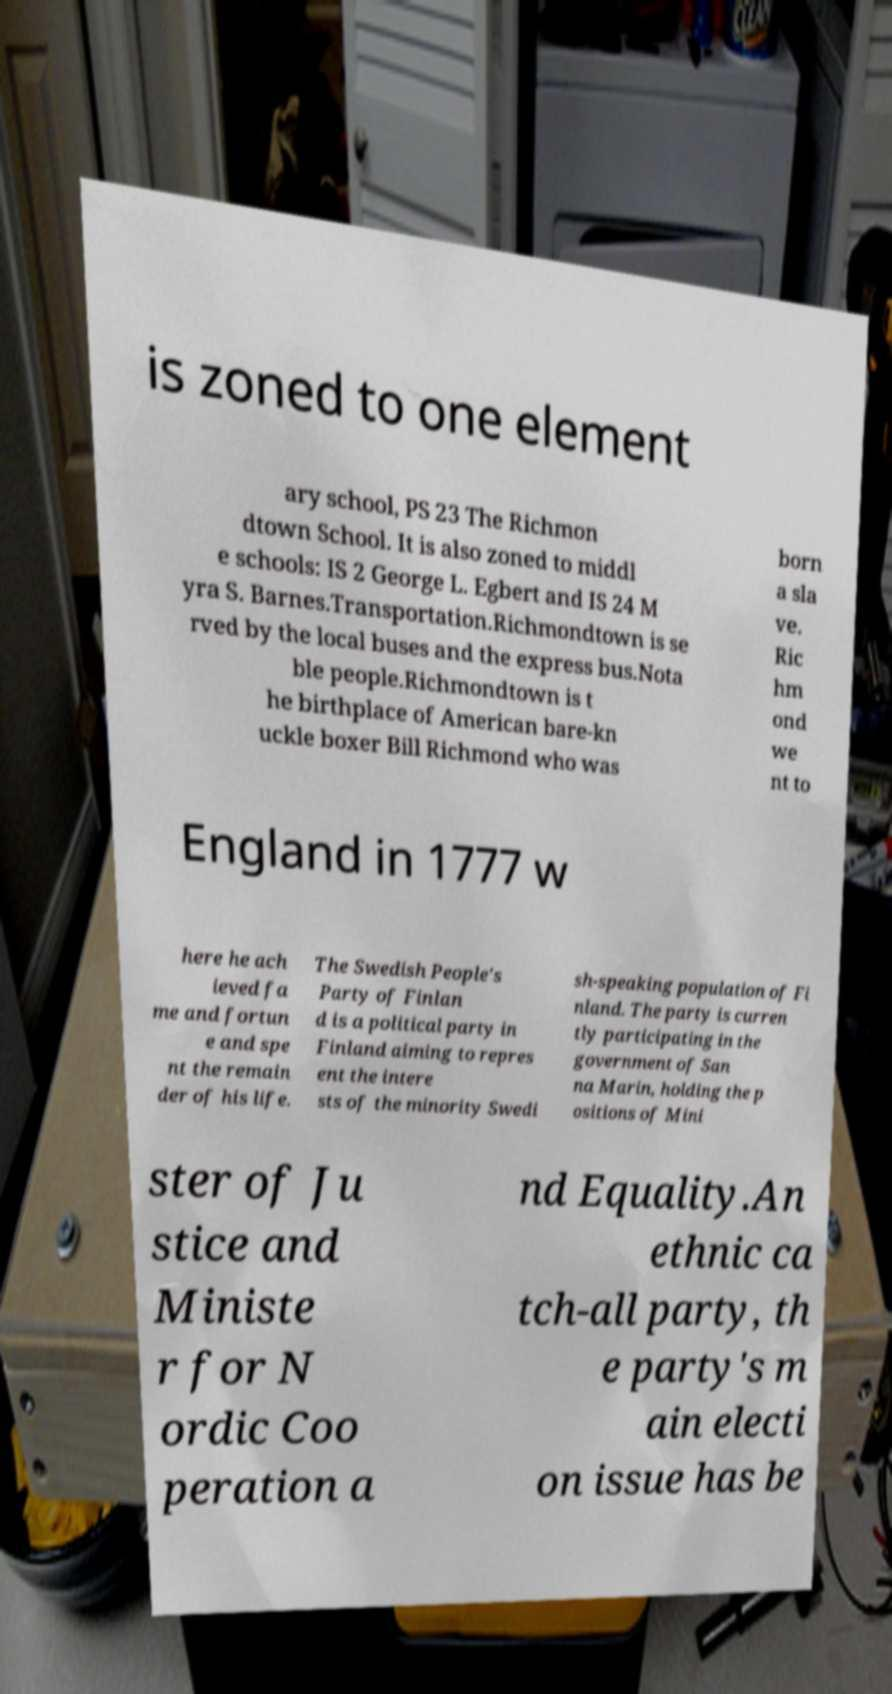I need the written content from this picture converted into text. Can you do that? is zoned to one element ary school, PS 23 The Richmon dtown School. It is also zoned to middl e schools: IS 2 George L. Egbert and IS 24 M yra S. Barnes.Transportation.Richmondtown is se rved by the local buses and the express bus.Nota ble people.Richmondtown is t he birthplace of American bare-kn uckle boxer Bill Richmond who was born a sla ve. Ric hm ond we nt to England in 1777 w here he ach ieved fa me and fortun e and spe nt the remain der of his life. The Swedish People's Party of Finlan d is a political party in Finland aiming to repres ent the intere sts of the minority Swedi sh-speaking population of Fi nland. The party is curren tly participating in the government of San na Marin, holding the p ositions of Mini ster of Ju stice and Ministe r for N ordic Coo peration a nd Equality.An ethnic ca tch-all party, th e party's m ain electi on issue has be 